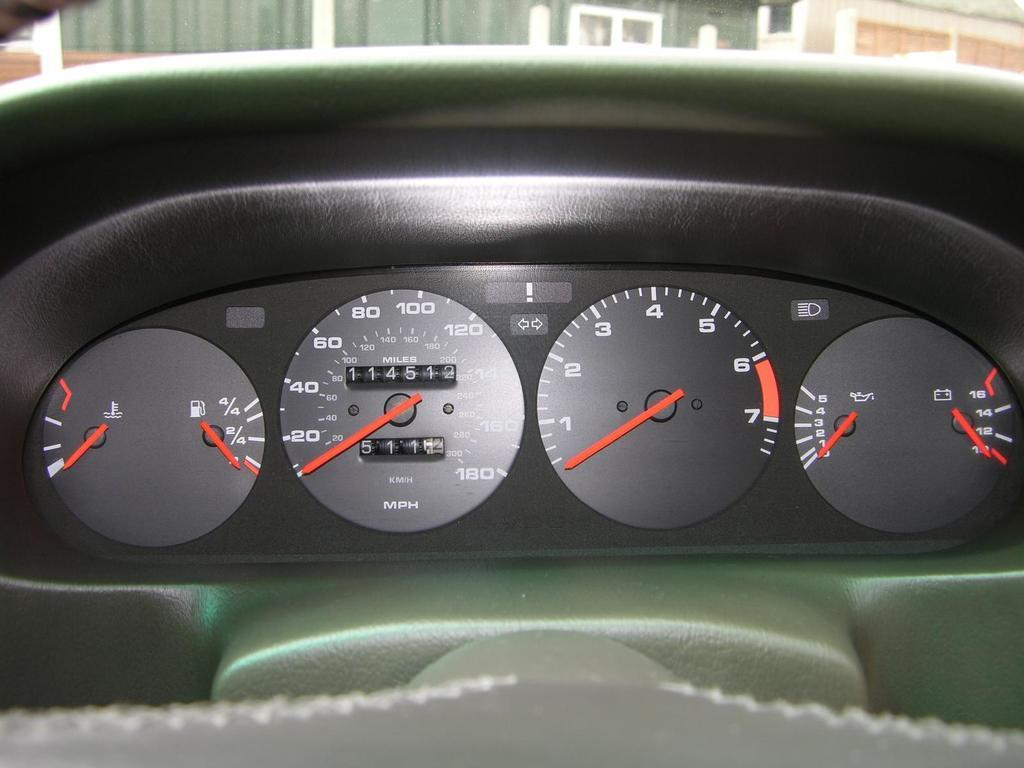What can be seen at the front of the image? There are meters in the front of the image. What colors and types of objects are visible in the background? There are green and white objects in the background of the image. What color are the objects in the meters? There are red color objects in the meters. How many pairs of shoes are visible in the image? There are no shoes present in the image. Where is the drawer located in the image? There is no drawer present in the image. 